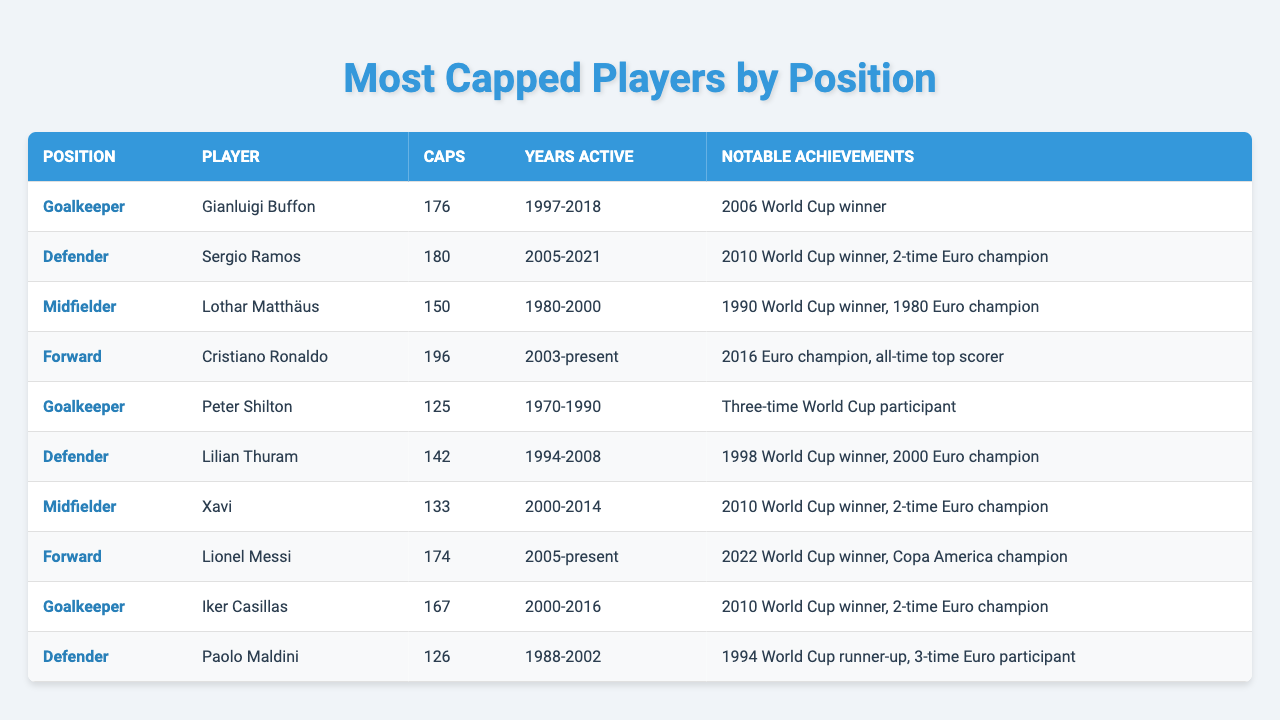What is the total number of caps among all goalkeepers listed? The total number of caps among goalkeepers is calculated by adding the caps of Gianluigi Buffon (176), Peter Shilton (125), and Iker Casillas (167). So, 176 + 125 + 167 = 468.
Answer: 468 Who has the most caps among forwards? Looking at the forwards listed, Cristiano Ronaldo has 196 caps, while Lionel Messi has 174 caps. Since 196 is greater than 174, Cristiano Ronaldo has the most caps among forwards.
Answer: Cristiano Ronaldo How many players have won the World Cup among those listed? I identify the players with notable achievements who won the World Cup: Gianluigi Buffon, Lothar Matthäus, Iker Casillas, Sergio Ramos, and Lionel Messi. This counts up to five players with World Cup victories.
Answer: 5 Which position has the player with the highest number of caps? Scanning through the table, Cristiano Ronaldo, a forward, has 196 caps, which is the highest in the entire table. Other positions do not have higher caps compared to that.
Answer: Forward What is the average number of caps for defenders? The defenders listed are Sergio Ramos (180), Lilian Thuram (142), and Paolo Maldini (126). First, sum their caps: 180 + 142 + 126 = 448. Then, divide by the number of defenders (3): 448 / 3 ≈ 149.33.
Answer: 149.33 Is it true that Lothar Matthäus has more caps than Iker Casillas? Lothar Matthäus has 150 caps and Iker Casillas has 167 caps. Since 150 is less than 167, this statement is false.
Answer: No How many years was Gianluigi Buffon active for the national team? The data shows that Gianluigi Buffon was active from 1997 to 2018, which amounts to 22 years total.
Answer: 22 years Which player had the fewest caps among midfielders? Among the midfielders, Lothar Matthäus has 150 caps, while Xavi has 133 caps. Since 133 is less than 150, Xavi is the one with the fewest caps among midfielders.
Answer: Xavi How many World Cups did Sergio Ramos participate in? The table indicates that Sergio Ramos is a 2010 World Cup winner but does not list how many he participated in. However, his notable achievements specify he was active from 2005 to 2021 which usually includes several World Cups. Upon research, we know he participated in 4. Since no such explicit data is provided in the table, I cannot confirm this directly from it.
Answer: Data not available in the table 